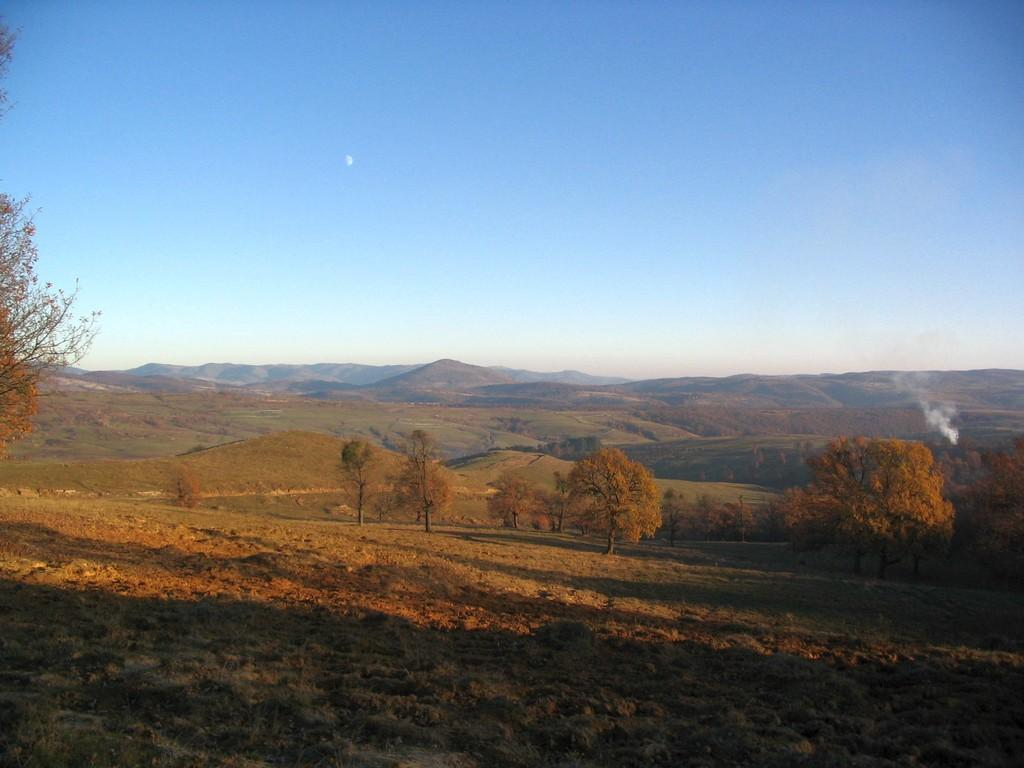What type of vegetation is at the bottom of the image? There is grass at the bottom of the image. What can be seen in the background of the image? There are trees and mountains in the background of the image. What is visible in the sky in the image? The sky is visible in the background of the image. Where is the maid in the image? There is no maid present in the image. What type of country is depicted in the image? The image does not depict a specific country; it only shows grass, trees, mountains, and the sky. 